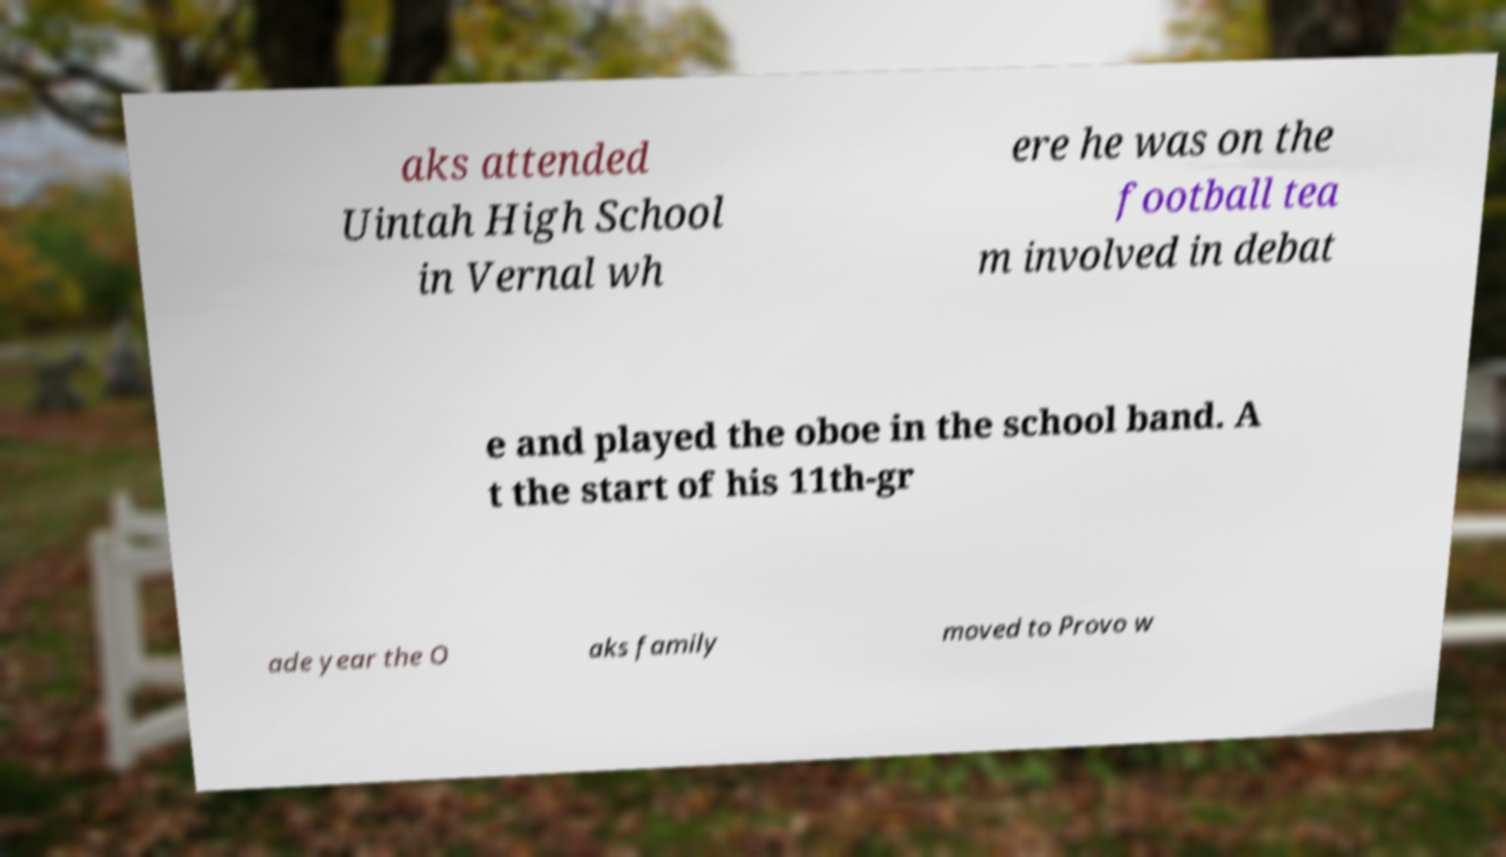What messages or text are displayed in this image? I need them in a readable, typed format. aks attended Uintah High School in Vernal wh ere he was on the football tea m involved in debat e and played the oboe in the school band. A t the start of his 11th-gr ade year the O aks family moved to Provo w 